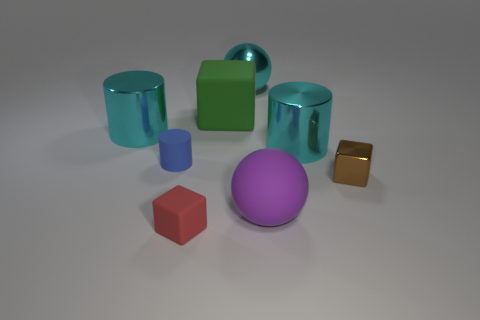Subtract all tiny rubber blocks. How many blocks are left? 2 Add 1 small red matte objects. How many objects exist? 9 Subtract all blue cylinders. How many cylinders are left? 2 Subtract 1 spheres. How many spheres are left? 1 Subtract all big blue matte spheres. Subtract all cyan metal cylinders. How many objects are left? 6 Add 1 big cyan cylinders. How many big cyan cylinders are left? 3 Add 1 large rubber cubes. How many large rubber cubes exist? 2 Subtract 1 purple balls. How many objects are left? 7 Subtract all cylinders. How many objects are left? 5 Subtract all brown cylinders. Subtract all red blocks. How many cylinders are left? 3 